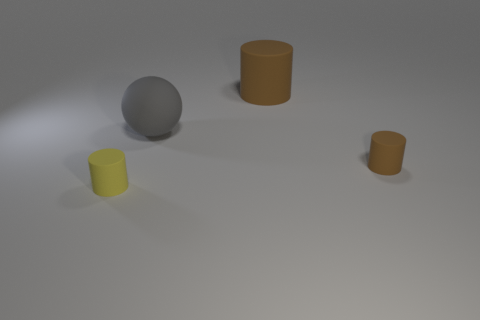Add 1 small shiny blocks. How many objects exist? 5 Subtract all cylinders. How many objects are left? 1 Add 1 gray matte spheres. How many gray matte spheres are left? 2 Add 1 brown matte things. How many brown matte things exist? 3 Subtract 0 cyan spheres. How many objects are left? 4 Subtract all brown rubber cylinders. Subtract all small brown matte cylinders. How many objects are left? 1 